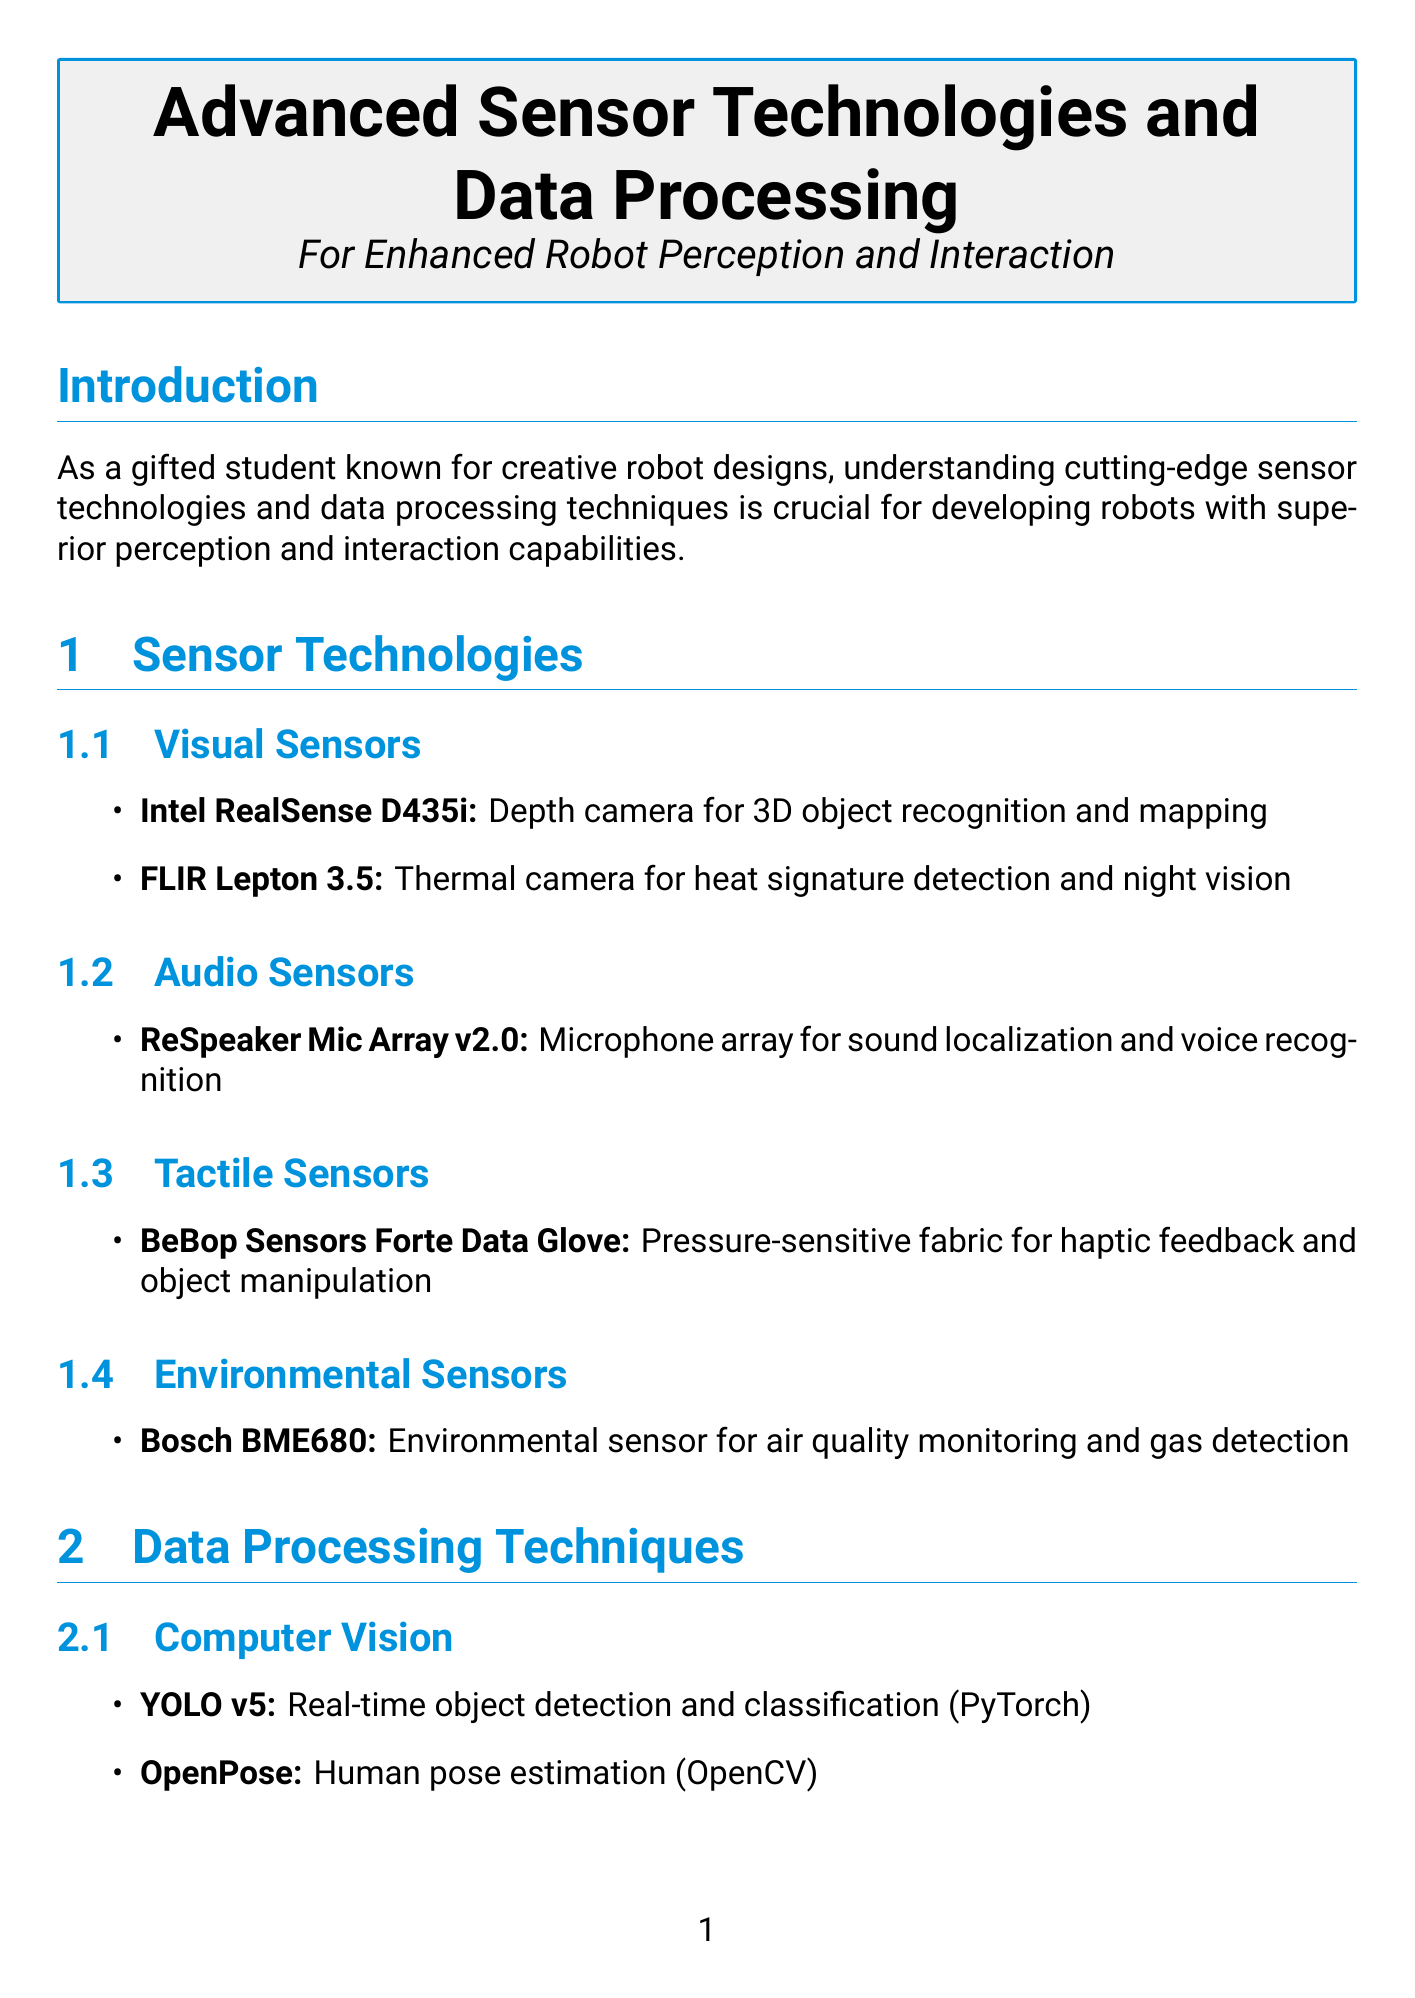What is the primary focus of this manual? The manual aims to provide insights into cutting-edge sensor technologies and data processing techniques for robotics.
Answer: Enhanced robot perception and interaction What is the application of the Intel RealSense D435i? The Intel RealSense D435i is used for 3D object recognition and mapping.
Answer: 3D object recognition and mapping Which data processing technique is used for speech-to-text conversion? DeepSpeech is identified as the algorithm for converting speech to text in the document.
Answer: DeepSpeech What sensor is used for environmental monitoring? The Bosch BME680 is referred to as the environmental sensor for air quality monitoring and gas detection.
Answer: Bosch BME680 What is the benefit of using Dynamic Time Warping in gesture recognition? The technique facilitates natural hand gesture-based interaction with the robot.
Answer: Enables natural hand gesture-based interaction How many audio sensors are listed in the document? There is one audio sensor mentioned in the sensor technologies section: ReSpeaker Mic Array v2.0.
Answer: One Which technique enhances natural and context-aware conversations with humans? The document mentions Transformer-based language models for this purpose.
Answer: Transformer-based language models What is the potential impact of neuromorphic sensors? Neuromorphic sensors aim to mimic human sensory processing for more efficient robots.
Answer: Mimicking human sensory processing What is listed as a tool for implementing SLAM? The manual specifies Google Cartographer as the tool for simultaneous localization and mapping.
Answer: Google Cartographer 